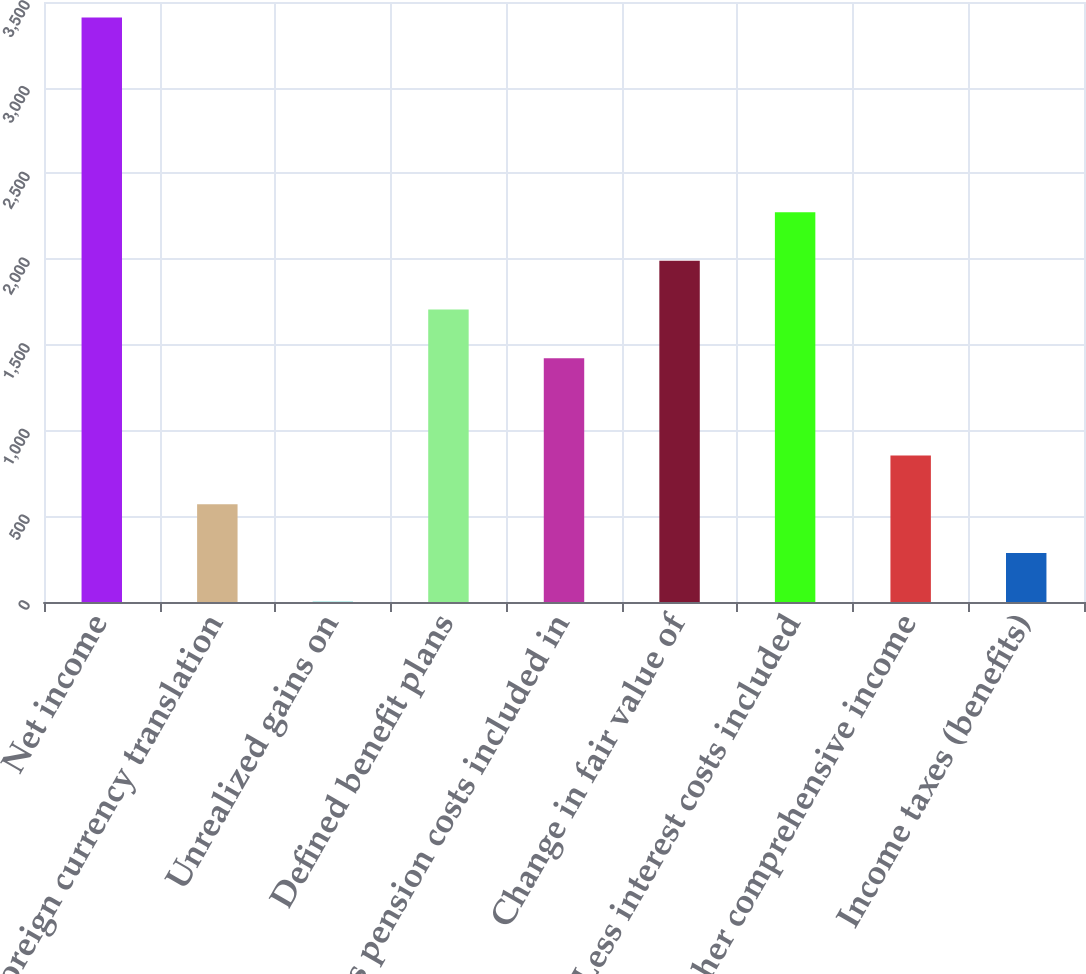<chart> <loc_0><loc_0><loc_500><loc_500><bar_chart><fcel>Net income<fcel>Foreign currency translation<fcel>Unrealized gains on<fcel>Defined benefit plans<fcel>Less pension costs included in<fcel>Change in fair value of<fcel>Less interest costs included<fcel>Other comprehensive income<fcel>Income taxes (benefits)<nl><fcel>3410<fcel>570<fcel>2<fcel>1706<fcel>1422<fcel>1990<fcel>2274<fcel>854<fcel>286<nl></chart> 